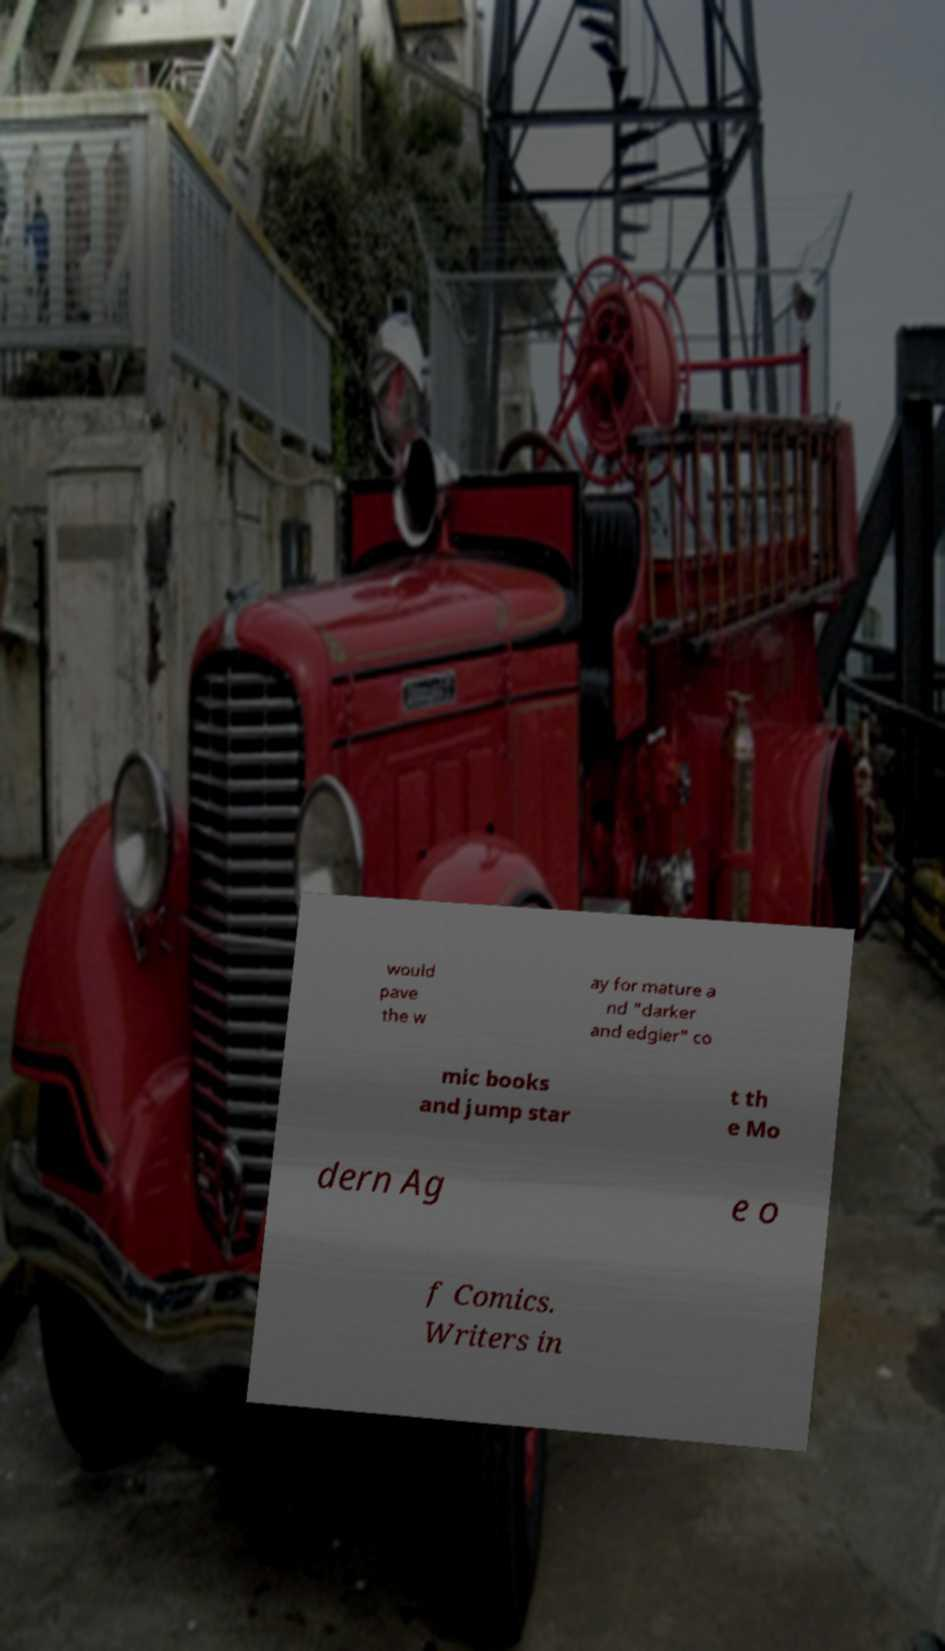What messages or text are displayed in this image? I need them in a readable, typed format. would pave the w ay for mature a nd "darker and edgier" co mic books and jump star t th e Mo dern Ag e o f Comics. Writers in 